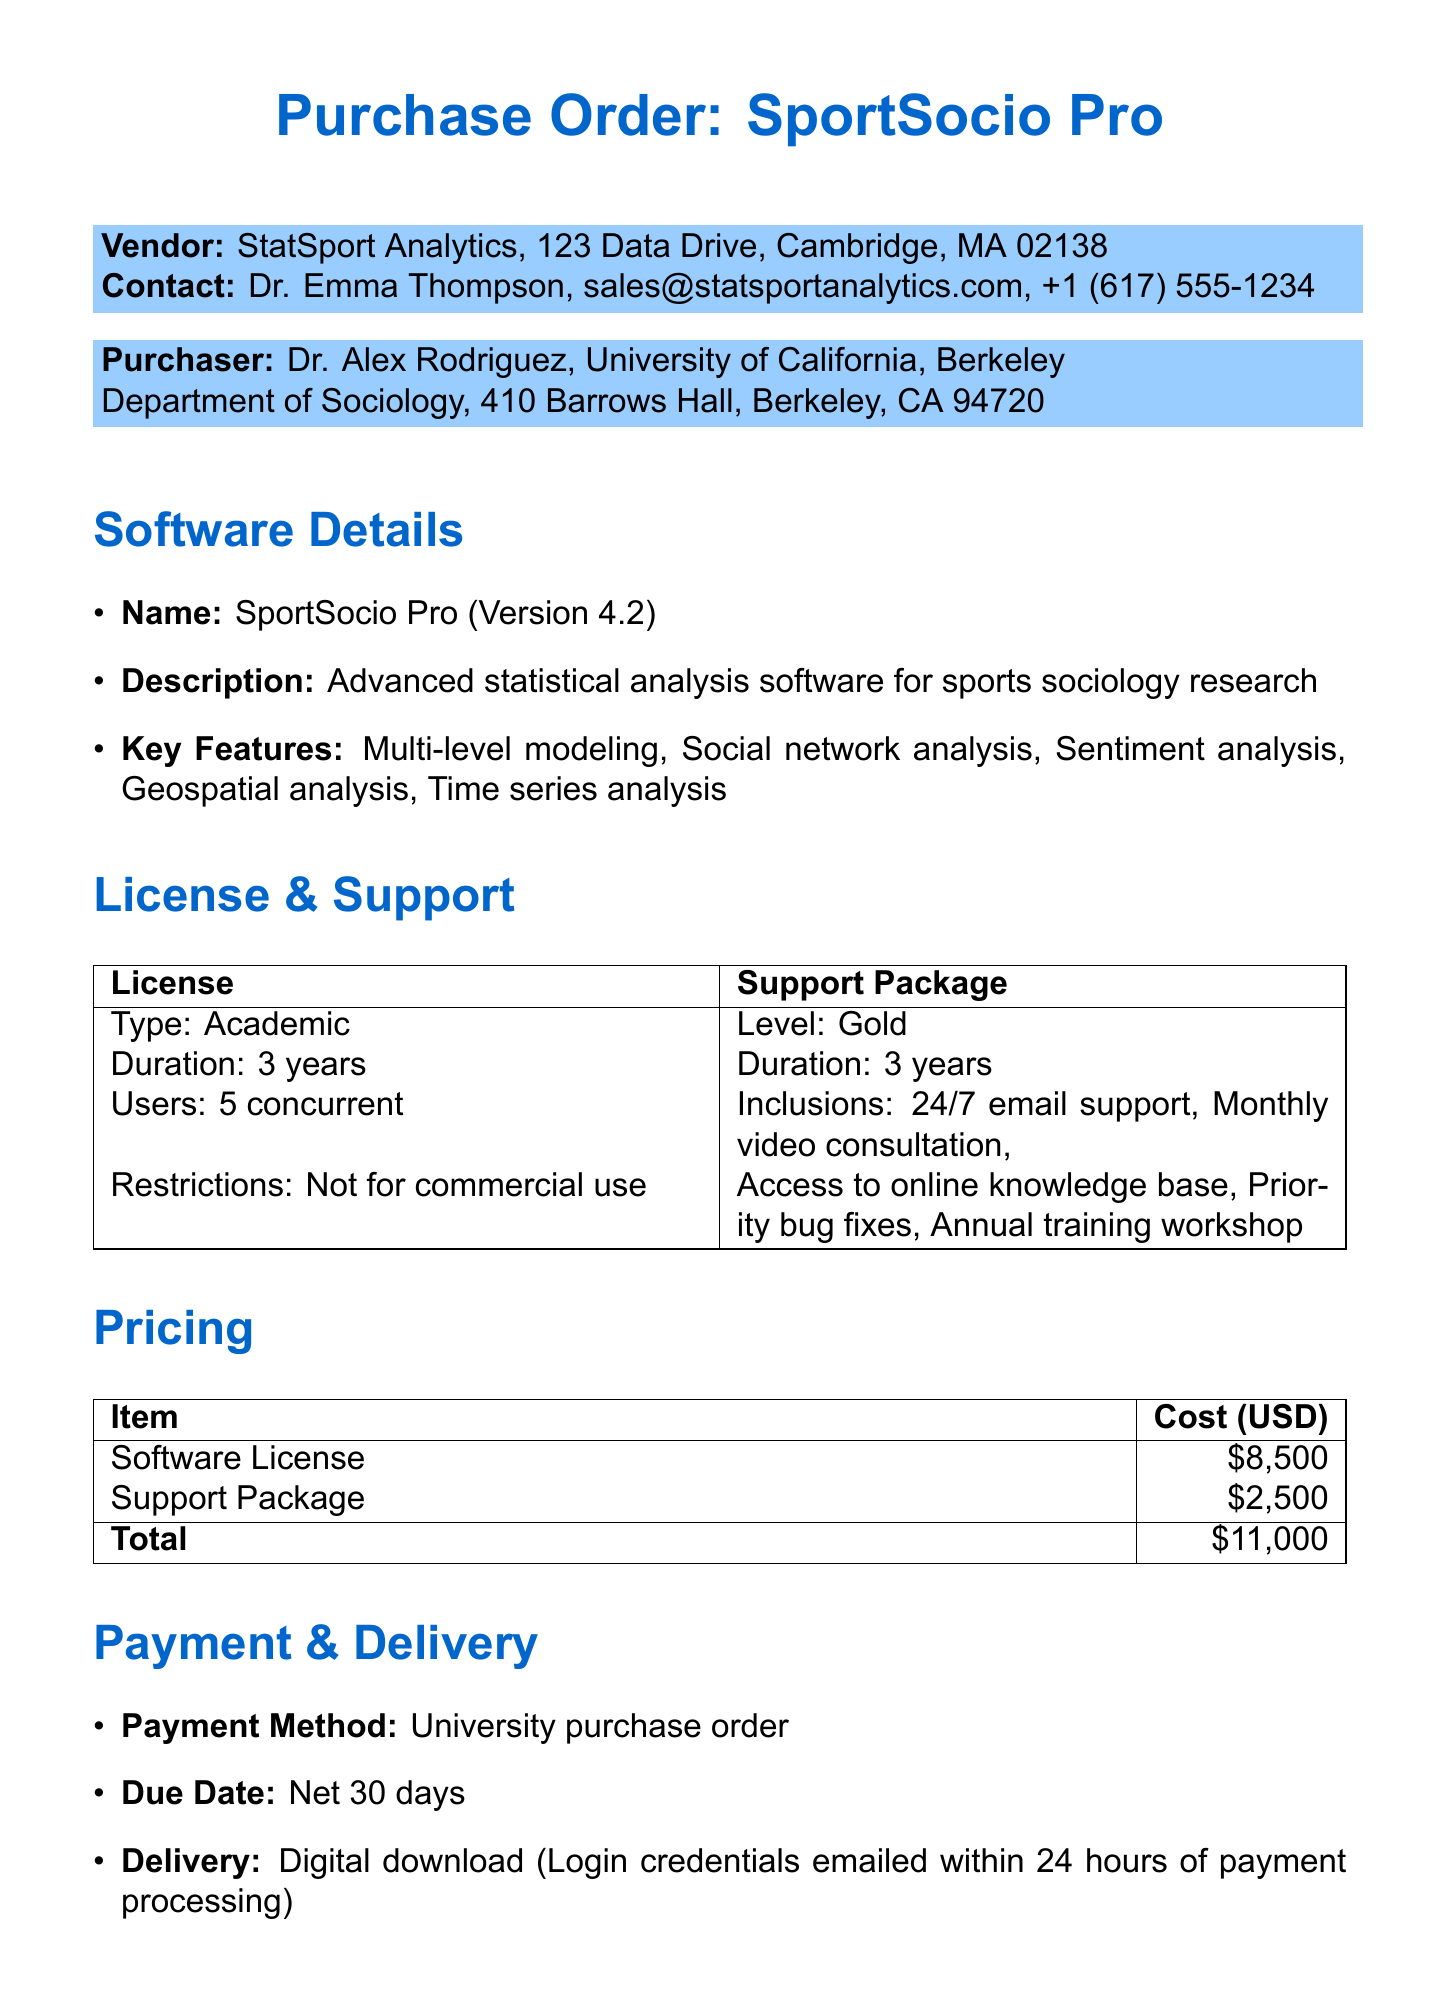What is the name of the software? The software mentioned in the document is SportSocio Pro.
Answer: SportSocio Pro What is the total cost of the purchase order? The total cost listed is the sum of the software license and support package, which totals $11,000.
Answer: $11,000 Who is the principal investigator of the research project? The document states that Dr. Alex Rodriguez is the principal investigator for the specified research project.
Answer: Dr. Alex Rodriguez What is the duration of the license? The document specifies that the license duration is for three years.
Answer: 3 years How many concurrent users does the license support? The license supports five concurrent users as stated in the document.
Answer: 5 concurrent users What is included in the Gold support package? The Gold support package includes 24/7 email support, monthly video consultations, access to online knowledge base, priority bug fixes, and annual training workshops.
Answer: 24/7 email support, monthly video consultations, access to online knowledge base, priority bug fixes, annual training workshops When is the payment due? The payment is due net 30 days according to the payment terms in the document.
Answer: Net 30 days What is the delivery method for the software? The delivery method indicated is a digital download, with login credentials emailed within 24 hours of payment processing.
Answer: Digital download What is the funding source for the research project? The National Science Foundation is mentioned as the funding source for the research project.
Answer: National Science Foundation 